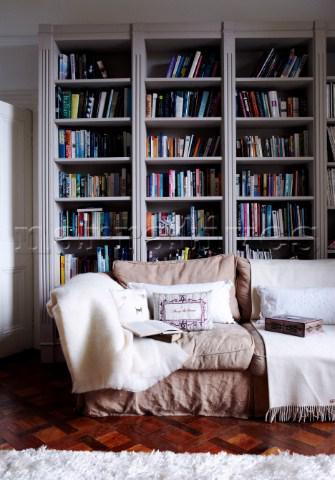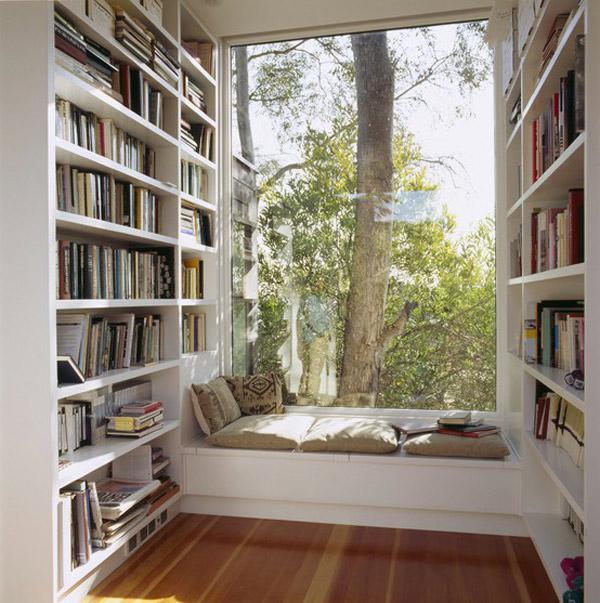The first image is the image on the left, the second image is the image on the right. Evaluate the accuracy of this statement regarding the images: "The bookshelf in the image on the left is near a window.". Is it true? Answer yes or no. No. The first image is the image on the left, the second image is the image on the right. For the images shown, is this caption "A room includes a beige couch in front of a white bookcase and behind a coffee table with slender legs." true? Answer yes or no. No. 